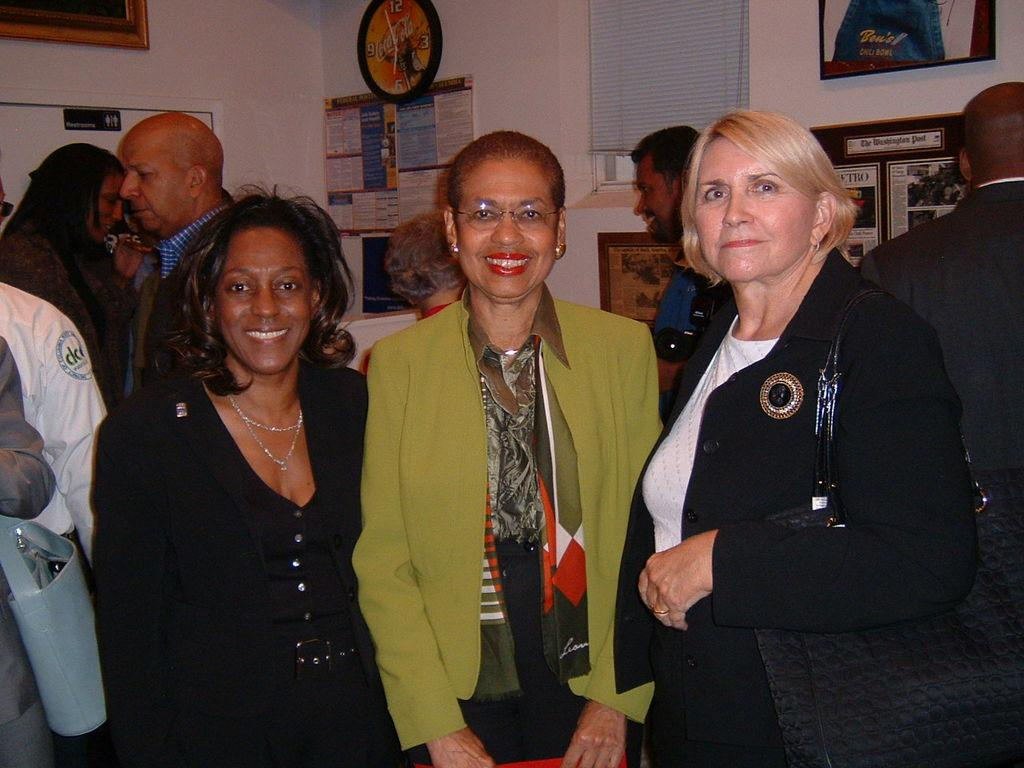What is happening in the image? There are people standing in the image. Can you describe the clothing of the people? The people are wearing different color dresses. What can be seen on the wall in the image? There are frames, a clock, and posters on the wall. Is there any source of natural light in the image? Yes, there is a window in the image. What type of fruit is bursting in the middle of the image? There is no fruit present in the image, let alone one that is bursting in the middle. 